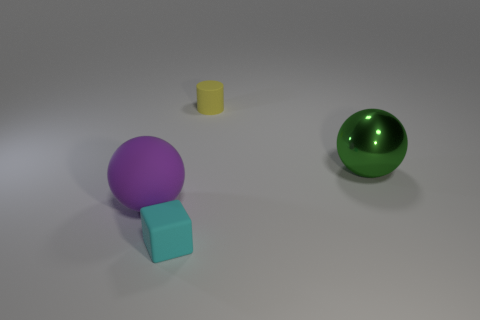Add 1 yellow cylinders. How many objects exist? 5 Subtract all cylinders. How many objects are left? 3 Subtract 0 yellow cubes. How many objects are left? 4 Subtract all cubes. Subtract all small yellow cylinders. How many objects are left? 2 Add 1 yellow objects. How many yellow objects are left? 2 Add 3 big gray rubber spheres. How many big gray rubber spheres exist? 3 